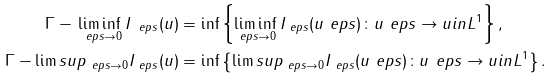<formula> <loc_0><loc_0><loc_500><loc_500>\Gamma - \liminf _ { \ e p s \to 0 } I _ { \ e p s } ( u ) & = \inf \left \{ \liminf _ { \ e p s \to 0 } I _ { \ e p s } ( u _ { \ } e p s ) \colon u _ { \ } e p s \to u i n L ^ { 1 } \right \} , \\ \Gamma - \lim s u p _ { \ e p s \to 0 } I _ { \ e p s } ( u ) & = \inf \left \{ \lim s u p _ { \ e p s \to 0 } I _ { \ e p s } ( u _ { \ } e p s ) \colon u _ { \ } e p s \to u i n L ^ { 1 } \right \} .</formula> 